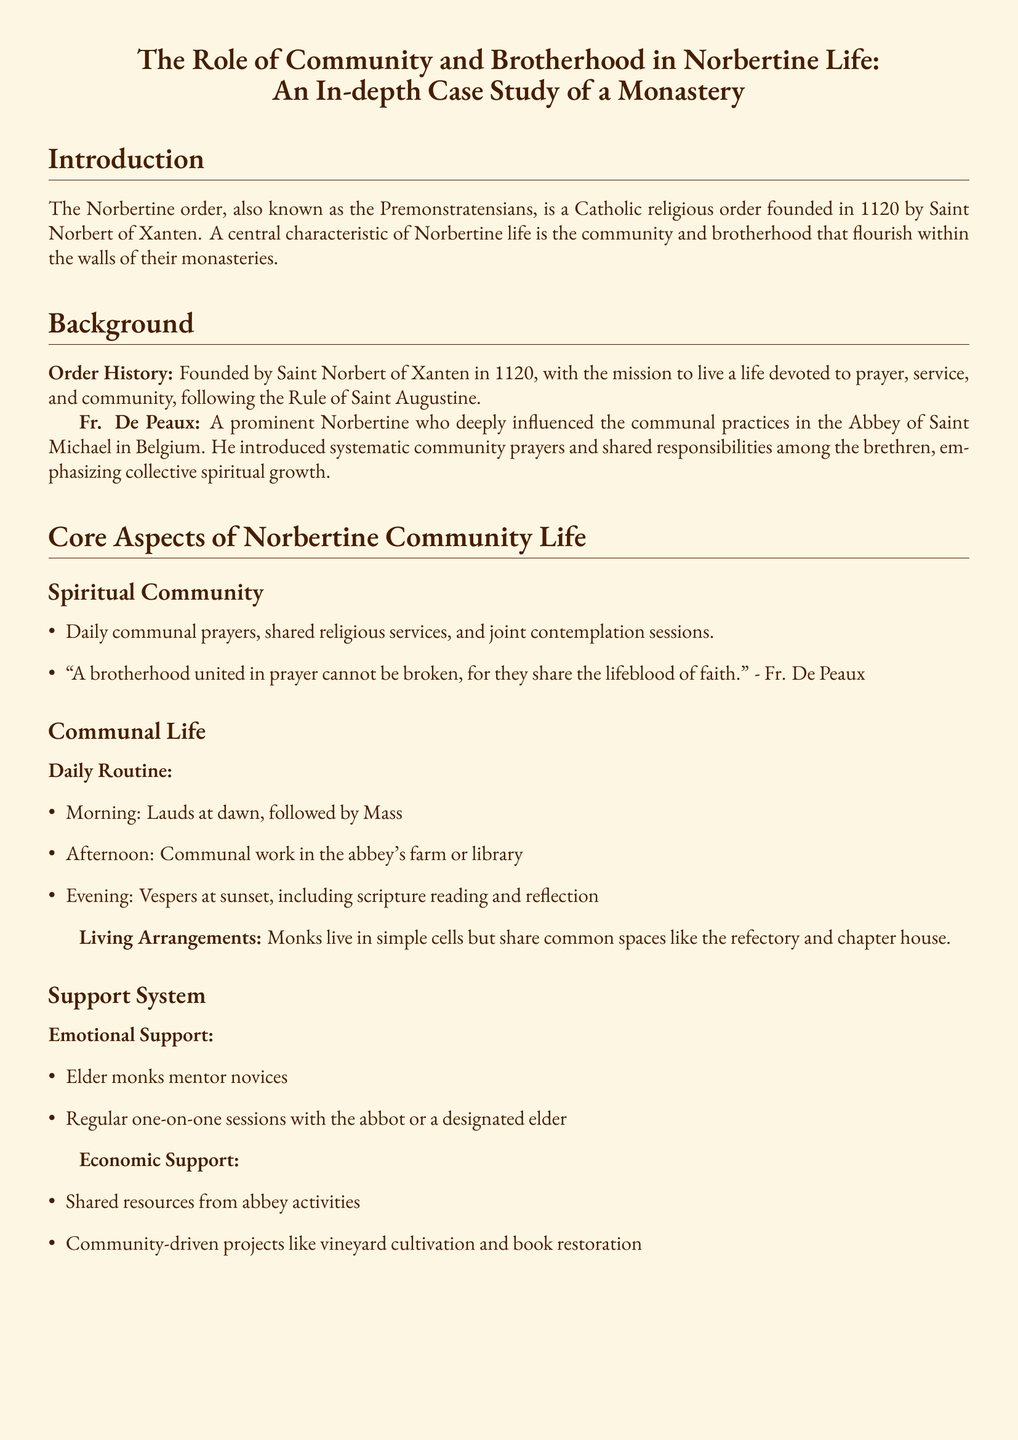What year was the Norbertine order founded? The founding year of the Norbertine order is explicitly stated in the document as 1120.
Answer: 1120 Who was a prominent Norbertine that influenced communal practices? The document mentions Fr. De Peaux as a significant figure regarding communal practices in the Abbey of Saint Michael.
Answer: Fr. De Peaux What is a key activity in the morning routine of the Norbertine community? The morning routine includes Lauds at dawn, which is specifically mentioned in the daily routine section.
Answer: Lauds What type of support do elder monks provide to novices? The document mentions that elder monks mentor novices, which indicates a form of support present in the community.
Answer: Mentor What unique activity is the Abbey of St. Michael known for? The case study section states that the Abbey of St. Michael is known for exceptional manuscript illuminations.
Answer: Manuscript illuminations What does the Norbertine model promote within the order? The conclusion emphasizes that the Norbertine model of community and brotherhood promotes resilience and collective growth.
Answer: Resilience and collective growth What kind of projects does the community engage in for economic support? The document details community-driven projects like vineyard cultivation, showcasing their approach to economic support.
Answer: Vineyard cultivation Who is quoted stating the fulfillment comes from serving the community? Brother Thomas is attributed as the one who reflects on fulfillment and serving the community according to the document.
Answer: Brother Thomas 